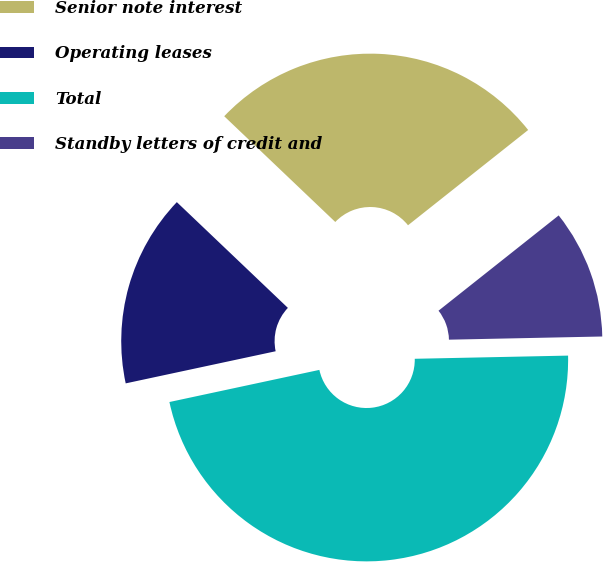<chart> <loc_0><loc_0><loc_500><loc_500><pie_chart><fcel>Senior note interest<fcel>Operating leases<fcel>Total<fcel>Standby letters of credit and<nl><fcel>27.22%<fcel>15.47%<fcel>46.97%<fcel>10.34%<nl></chart> 